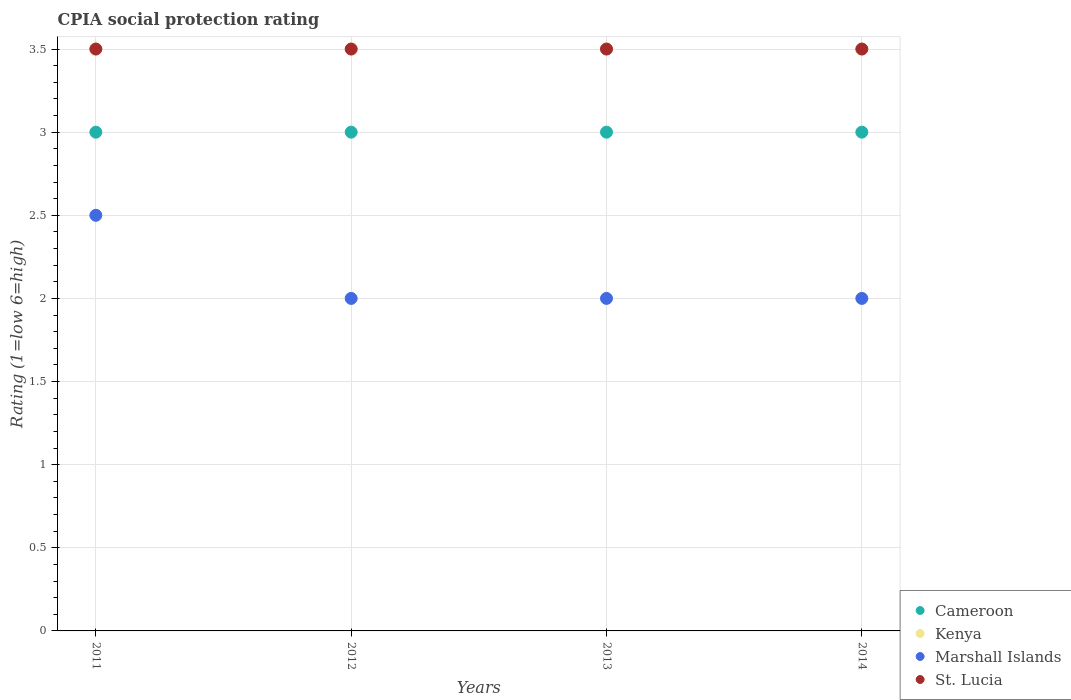What is the CPIA rating in Cameroon in 2013?
Your answer should be very brief. 3. Across all years, what is the maximum CPIA rating in Marshall Islands?
Give a very brief answer. 2.5. Across all years, what is the minimum CPIA rating in Kenya?
Your answer should be compact. 3.5. In which year was the CPIA rating in Marshall Islands maximum?
Provide a short and direct response. 2011. In which year was the CPIA rating in Marshall Islands minimum?
Your response must be concise. 2012. What is the difference between the CPIA rating in Marshall Islands in 2014 and the CPIA rating in St. Lucia in 2012?
Make the answer very short. -1.5. In the year 2014, what is the difference between the CPIA rating in Kenya and CPIA rating in Marshall Islands?
Provide a short and direct response. 1.5. In how many years, is the CPIA rating in Cameroon greater than 1.1?
Ensure brevity in your answer.  4. What is the ratio of the CPIA rating in St. Lucia in 2012 to that in 2013?
Provide a short and direct response. 1. Is the difference between the CPIA rating in Kenya in 2013 and 2014 greater than the difference between the CPIA rating in Marshall Islands in 2013 and 2014?
Provide a short and direct response. No. What is the difference between the highest and the second highest CPIA rating in Kenya?
Offer a very short reply. 0. Is it the case that in every year, the sum of the CPIA rating in St. Lucia and CPIA rating in Marshall Islands  is greater than the CPIA rating in Cameroon?
Make the answer very short. Yes. Does the CPIA rating in Cameroon monotonically increase over the years?
Keep it short and to the point. No. Is the CPIA rating in Marshall Islands strictly less than the CPIA rating in Kenya over the years?
Offer a very short reply. Yes. How many dotlines are there?
Provide a short and direct response. 4. Does the graph contain any zero values?
Make the answer very short. No. Does the graph contain grids?
Offer a terse response. Yes. Where does the legend appear in the graph?
Your response must be concise. Bottom right. How many legend labels are there?
Your answer should be compact. 4. How are the legend labels stacked?
Keep it short and to the point. Vertical. What is the title of the graph?
Your answer should be compact. CPIA social protection rating. What is the label or title of the X-axis?
Offer a very short reply. Years. What is the label or title of the Y-axis?
Provide a succinct answer. Rating (1=low 6=high). What is the Rating (1=low 6=high) of Cameroon in 2011?
Offer a terse response. 3. What is the Rating (1=low 6=high) in Kenya in 2011?
Your response must be concise. 3.5. What is the Rating (1=low 6=high) of Marshall Islands in 2011?
Offer a terse response. 2.5. What is the Rating (1=low 6=high) of Cameroon in 2012?
Offer a terse response. 3. What is the Rating (1=low 6=high) of Kenya in 2012?
Your answer should be compact. 3.5. What is the Rating (1=low 6=high) in Marshall Islands in 2012?
Make the answer very short. 2. What is the Rating (1=low 6=high) of St. Lucia in 2012?
Your answer should be very brief. 3.5. What is the Rating (1=low 6=high) in St. Lucia in 2013?
Ensure brevity in your answer.  3.5. What is the Rating (1=low 6=high) in Marshall Islands in 2014?
Your response must be concise. 2. Across all years, what is the maximum Rating (1=low 6=high) of Marshall Islands?
Your answer should be very brief. 2.5. Across all years, what is the maximum Rating (1=low 6=high) of St. Lucia?
Your response must be concise. 3.5. Across all years, what is the minimum Rating (1=low 6=high) of Kenya?
Provide a succinct answer. 3.5. Across all years, what is the minimum Rating (1=low 6=high) in Marshall Islands?
Offer a terse response. 2. What is the total Rating (1=low 6=high) in Kenya in the graph?
Provide a short and direct response. 14. What is the total Rating (1=low 6=high) of St. Lucia in the graph?
Offer a terse response. 14. What is the difference between the Rating (1=low 6=high) of Cameroon in 2011 and that in 2012?
Give a very brief answer. 0. What is the difference between the Rating (1=low 6=high) of Kenya in 2011 and that in 2012?
Make the answer very short. 0. What is the difference between the Rating (1=low 6=high) in Marshall Islands in 2011 and that in 2012?
Your response must be concise. 0.5. What is the difference between the Rating (1=low 6=high) in St. Lucia in 2011 and that in 2012?
Your response must be concise. 0. What is the difference between the Rating (1=low 6=high) of Cameroon in 2011 and that in 2013?
Make the answer very short. 0. What is the difference between the Rating (1=low 6=high) in Kenya in 2011 and that in 2013?
Offer a terse response. 0. What is the difference between the Rating (1=low 6=high) of St. Lucia in 2011 and that in 2013?
Provide a short and direct response. 0. What is the difference between the Rating (1=low 6=high) of Marshall Islands in 2011 and that in 2014?
Offer a very short reply. 0.5. What is the difference between the Rating (1=low 6=high) of St. Lucia in 2011 and that in 2014?
Ensure brevity in your answer.  0. What is the difference between the Rating (1=low 6=high) in Marshall Islands in 2012 and that in 2013?
Offer a terse response. 0. What is the difference between the Rating (1=low 6=high) of St. Lucia in 2012 and that in 2013?
Offer a very short reply. 0. What is the difference between the Rating (1=low 6=high) of Marshall Islands in 2012 and that in 2014?
Offer a very short reply. 0. What is the difference between the Rating (1=low 6=high) of Kenya in 2013 and that in 2014?
Give a very brief answer. 0. What is the difference between the Rating (1=low 6=high) of St. Lucia in 2013 and that in 2014?
Provide a short and direct response. 0. What is the difference between the Rating (1=low 6=high) of Cameroon in 2011 and the Rating (1=low 6=high) of Kenya in 2013?
Offer a terse response. -0.5. What is the difference between the Rating (1=low 6=high) in Cameroon in 2011 and the Rating (1=low 6=high) in St. Lucia in 2013?
Keep it short and to the point. -0.5. What is the difference between the Rating (1=low 6=high) in Kenya in 2011 and the Rating (1=low 6=high) in Marshall Islands in 2013?
Offer a very short reply. 1.5. What is the difference between the Rating (1=low 6=high) of Cameroon in 2011 and the Rating (1=low 6=high) of St. Lucia in 2014?
Your answer should be very brief. -0.5. What is the difference between the Rating (1=low 6=high) in Cameroon in 2012 and the Rating (1=low 6=high) in Kenya in 2013?
Offer a terse response. -0.5. What is the difference between the Rating (1=low 6=high) of Cameroon in 2012 and the Rating (1=low 6=high) of St. Lucia in 2013?
Offer a very short reply. -0.5. What is the difference between the Rating (1=low 6=high) of Kenya in 2012 and the Rating (1=low 6=high) of St. Lucia in 2013?
Your answer should be very brief. 0. What is the difference between the Rating (1=low 6=high) in Cameroon in 2012 and the Rating (1=low 6=high) in Marshall Islands in 2014?
Give a very brief answer. 1. What is the difference between the Rating (1=low 6=high) in Marshall Islands in 2012 and the Rating (1=low 6=high) in St. Lucia in 2014?
Your answer should be very brief. -1.5. What is the difference between the Rating (1=low 6=high) in Cameroon in 2013 and the Rating (1=low 6=high) in Kenya in 2014?
Offer a terse response. -0.5. What is the difference between the Rating (1=low 6=high) of Cameroon in 2013 and the Rating (1=low 6=high) of Marshall Islands in 2014?
Ensure brevity in your answer.  1. What is the difference between the Rating (1=low 6=high) of Kenya in 2013 and the Rating (1=low 6=high) of Marshall Islands in 2014?
Provide a short and direct response. 1.5. What is the difference between the Rating (1=low 6=high) of Kenya in 2013 and the Rating (1=low 6=high) of St. Lucia in 2014?
Your answer should be very brief. 0. What is the difference between the Rating (1=low 6=high) in Marshall Islands in 2013 and the Rating (1=low 6=high) in St. Lucia in 2014?
Offer a very short reply. -1.5. What is the average Rating (1=low 6=high) in Marshall Islands per year?
Your answer should be compact. 2.12. What is the average Rating (1=low 6=high) in St. Lucia per year?
Provide a short and direct response. 3.5. In the year 2011, what is the difference between the Rating (1=low 6=high) in Cameroon and Rating (1=low 6=high) in Kenya?
Offer a terse response. -0.5. In the year 2011, what is the difference between the Rating (1=low 6=high) of Cameroon and Rating (1=low 6=high) of Marshall Islands?
Provide a short and direct response. 0.5. In the year 2011, what is the difference between the Rating (1=low 6=high) in Cameroon and Rating (1=low 6=high) in St. Lucia?
Keep it short and to the point. -0.5. In the year 2011, what is the difference between the Rating (1=low 6=high) in Kenya and Rating (1=low 6=high) in Marshall Islands?
Keep it short and to the point. 1. In the year 2011, what is the difference between the Rating (1=low 6=high) in Marshall Islands and Rating (1=low 6=high) in St. Lucia?
Ensure brevity in your answer.  -1. In the year 2012, what is the difference between the Rating (1=low 6=high) of Cameroon and Rating (1=low 6=high) of Kenya?
Provide a short and direct response. -0.5. In the year 2012, what is the difference between the Rating (1=low 6=high) in Cameroon and Rating (1=low 6=high) in Marshall Islands?
Provide a short and direct response. 1. In the year 2012, what is the difference between the Rating (1=low 6=high) of Cameroon and Rating (1=low 6=high) of St. Lucia?
Ensure brevity in your answer.  -0.5. In the year 2012, what is the difference between the Rating (1=low 6=high) of Kenya and Rating (1=low 6=high) of Marshall Islands?
Your answer should be compact. 1.5. In the year 2012, what is the difference between the Rating (1=low 6=high) in Marshall Islands and Rating (1=low 6=high) in St. Lucia?
Provide a short and direct response. -1.5. In the year 2013, what is the difference between the Rating (1=low 6=high) of Cameroon and Rating (1=low 6=high) of Kenya?
Keep it short and to the point. -0.5. In the year 2013, what is the difference between the Rating (1=low 6=high) in Cameroon and Rating (1=low 6=high) in Marshall Islands?
Your answer should be compact. 1. In the year 2013, what is the difference between the Rating (1=low 6=high) in Kenya and Rating (1=low 6=high) in Marshall Islands?
Make the answer very short. 1.5. In the year 2013, what is the difference between the Rating (1=low 6=high) of Marshall Islands and Rating (1=low 6=high) of St. Lucia?
Your answer should be very brief. -1.5. In the year 2014, what is the difference between the Rating (1=low 6=high) of Cameroon and Rating (1=low 6=high) of Kenya?
Provide a short and direct response. -0.5. In the year 2014, what is the difference between the Rating (1=low 6=high) in Kenya and Rating (1=low 6=high) in Marshall Islands?
Provide a short and direct response. 1.5. What is the ratio of the Rating (1=low 6=high) in Kenya in 2011 to that in 2012?
Your answer should be very brief. 1. What is the ratio of the Rating (1=low 6=high) of Marshall Islands in 2011 to that in 2012?
Ensure brevity in your answer.  1.25. What is the ratio of the Rating (1=low 6=high) in Cameroon in 2011 to that in 2013?
Your answer should be compact. 1. What is the ratio of the Rating (1=low 6=high) of Cameroon in 2011 to that in 2014?
Your answer should be compact. 1. What is the ratio of the Rating (1=low 6=high) in St. Lucia in 2011 to that in 2014?
Keep it short and to the point. 1. What is the ratio of the Rating (1=low 6=high) of Kenya in 2012 to that in 2013?
Provide a succinct answer. 1. What is the ratio of the Rating (1=low 6=high) in Marshall Islands in 2012 to that in 2013?
Keep it short and to the point. 1. What is the ratio of the Rating (1=low 6=high) in St. Lucia in 2012 to that in 2013?
Ensure brevity in your answer.  1. What is the ratio of the Rating (1=low 6=high) in Kenya in 2012 to that in 2014?
Ensure brevity in your answer.  1. What is the ratio of the Rating (1=low 6=high) in Marshall Islands in 2012 to that in 2014?
Your answer should be very brief. 1. What is the ratio of the Rating (1=low 6=high) in Marshall Islands in 2013 to that in 2014?
Ensure brevity in your answer.  1. What is the ratio of the Rating (1=low 6=high) in St. Lucia in 2013 to that in 2014?
Your answer should be compact. 1. What is the difference between the highest and the second highest Rating (1=low 6=high) of Kenya?
Your response must be concise. 0. What is the difference between the highest and the second highest Rating (1=low 6=high) of Marshall Islands?
Offer a very short reply. 0.5. What is the difference between the highest and the second highest Rating (1=low 6=high) of St. Lucia?
Provide a short and direct response. 0. What is the difference between the highest and the lowest Rating (1=low 6=high) of Cameroon?
Your response must be concise. 0. What is the difference between the highest and the lowest Rating (1=low 6=high) in Kenya?
Provide a succinct answer. 0. What is the difference between the highest and the lowest Rating (1=low 6=high) in Marshall Islands?
Ensure brevity in your answer.  0.5. 